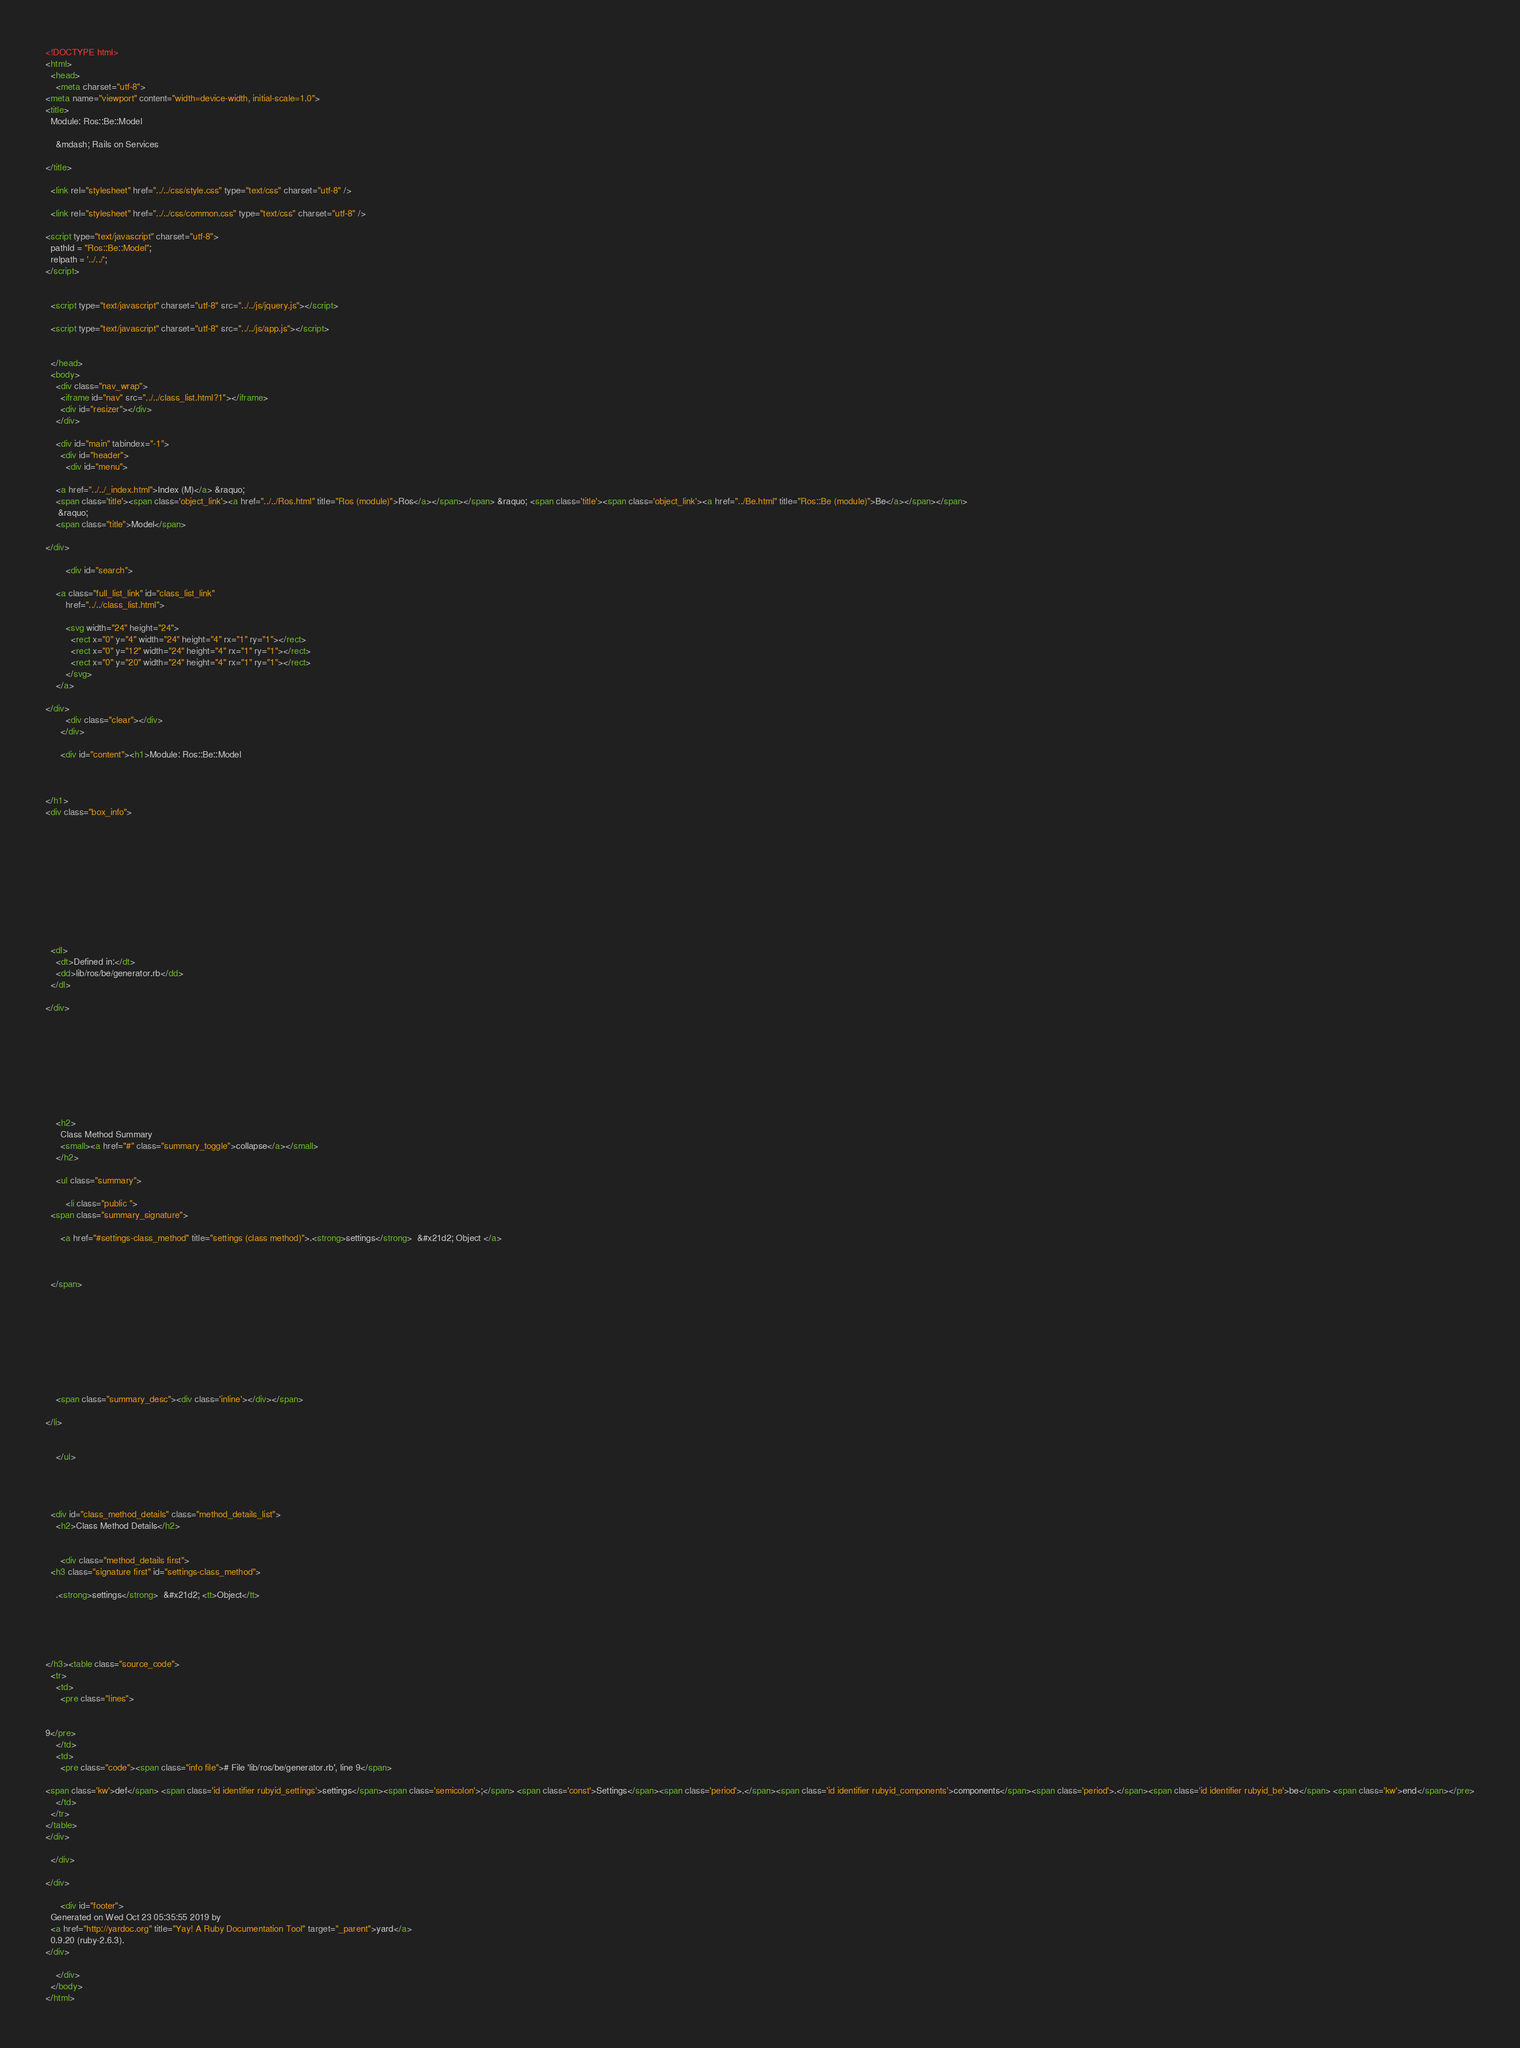<code> <loc_0><loc_0><loc_500><loc_500><_HTML_><!DOCTYPE html>
<html>
  <head>
    <meta charset="utf-8">
<meta name="viewport" content="width=device-width, initial-scale=1.0">
<title>
  Module: Ros::Be::Model
  
    &mdash; Rails on Services
  
</title>

  <link rel="stylesheet" href="../../css/style.css" type="text/css" charset="utf-8" />

  <link rel="stylesheet" href="../../css/common.css" type="text/css" charset="utf-8" />

<script type="text/javascript" charset="utf-8">
  pathId = "Ros::Be::Model";
  relpath = '../../';
</script>


  <script type="text/javascript" charset="utf-8" src="../../js/jquery.js"></script>

  <script type="text/javascript" charset="utf-8" src="../../js/app.js"></script>


  </head>
  <body>
    <div class="nav_wrap">
      <iframe id="nav" src="../../class_list.html?1"></iframe>
      <div id="resizer"></div>
    </div>

    <div id="main" tabindex="-1">
      <div id="header">
        <div id="menu">
  
    <a href="../../_index.html">Index (M)</a> &raquo;
    <span class='title'><span class='object_link'><a href="../../Ros.html" title="Ros (module)">Ros</a></span></span> &raquo; <span class='title'><span class='object_link'><a href="../Be.html" title="Ros::Be (module)">Be</a></span></span>
     &raquo; 
    <span class="title">Model</span>
  
</div>

        <div id="search">
  
    <a class="full_list_link" id="class_list_link"
        href="../../class_list.html">

        <svg width="24" height="24">
          <rect x="0" y="4" width="24" height="4" rx="1" ry="1"></rect>
          <rect x="0" y="12" width="24" height="4" rx="1" ry="1"></rect>
          <rect x="0" y="20" width="24" height="4" rx="1" ry="1"></rect>
        </svg>
    </a>
  
</div>
        <div class="clear"></div>
      </div>

      <div id="content"><h1>Module: Ros::Be::Model
  
  
  
</h1>
<div class="box_info">
  

  
  
  
  
  

  

  
  <dl>
    <dt>Defined in:</dt>
    <dd>lib/ros/be/generator.rb</dd>
  </dl>
  
</div>








  
    <h2>
      Class Method Summary
      <small><a href="#" class="summary_toggle">collapse</a></small>
    </h2>

    <ul class="summary">
      
        <li class="public ">
  <span class="summary_signature">
    
      <a href="#settings-class_method" title="settings (class method)">.<strong>settings</strong>  &#x21d2; Object </a>
    

    
  </span>
  
  
  
  
  
  
  

  
    <span class="summary_desc"><div class='inline'></div></span>
  
</li>

      
    </ul>
  



  <div id="class_method_details" class="method_details_list">
    <h2>Class Method Details</h2>

    
      <div class="method_details first">
  <h3 class="signature first" id="settings-class_method">
  
    .<strong>settings</strong>  &#x21d2; <tt>Object</tt> 
  

  

  
</h3><table class="source_code">
  <tr>
    <td>
      <pre class="lines">


9</pre>
    </td>
    <td>
      <pre class="code"><span class="info file"># File 'lib/ros/be/generator.rb', line 9</span>

<span class='kw'>def</span> <span class='id identifier rubyid_settings'>settings</span><span class='semicolon'>;</span> <span class='const'>Settings</span><span class='period'>.</span><span class='id identifier rubyid_components'>components</span><span class='period'>.</span><span class='id identifier rubyid_be'>be</span> <span class='kw'>end</span></pre>
    </td>
  </tr>
</table>
</div>
    
  </div>

</div>

      <div id="footer">
  Generated on Wed Oct 23 05:35:55 2019 by
  <a href="http://yardoc.org" title="Yay! A Ruby Documentation Tool" target="_parent">yard</a>
  0.9.20 (ruby-2.6.3).
</div>

    </div>
  </body>
</html></code> 